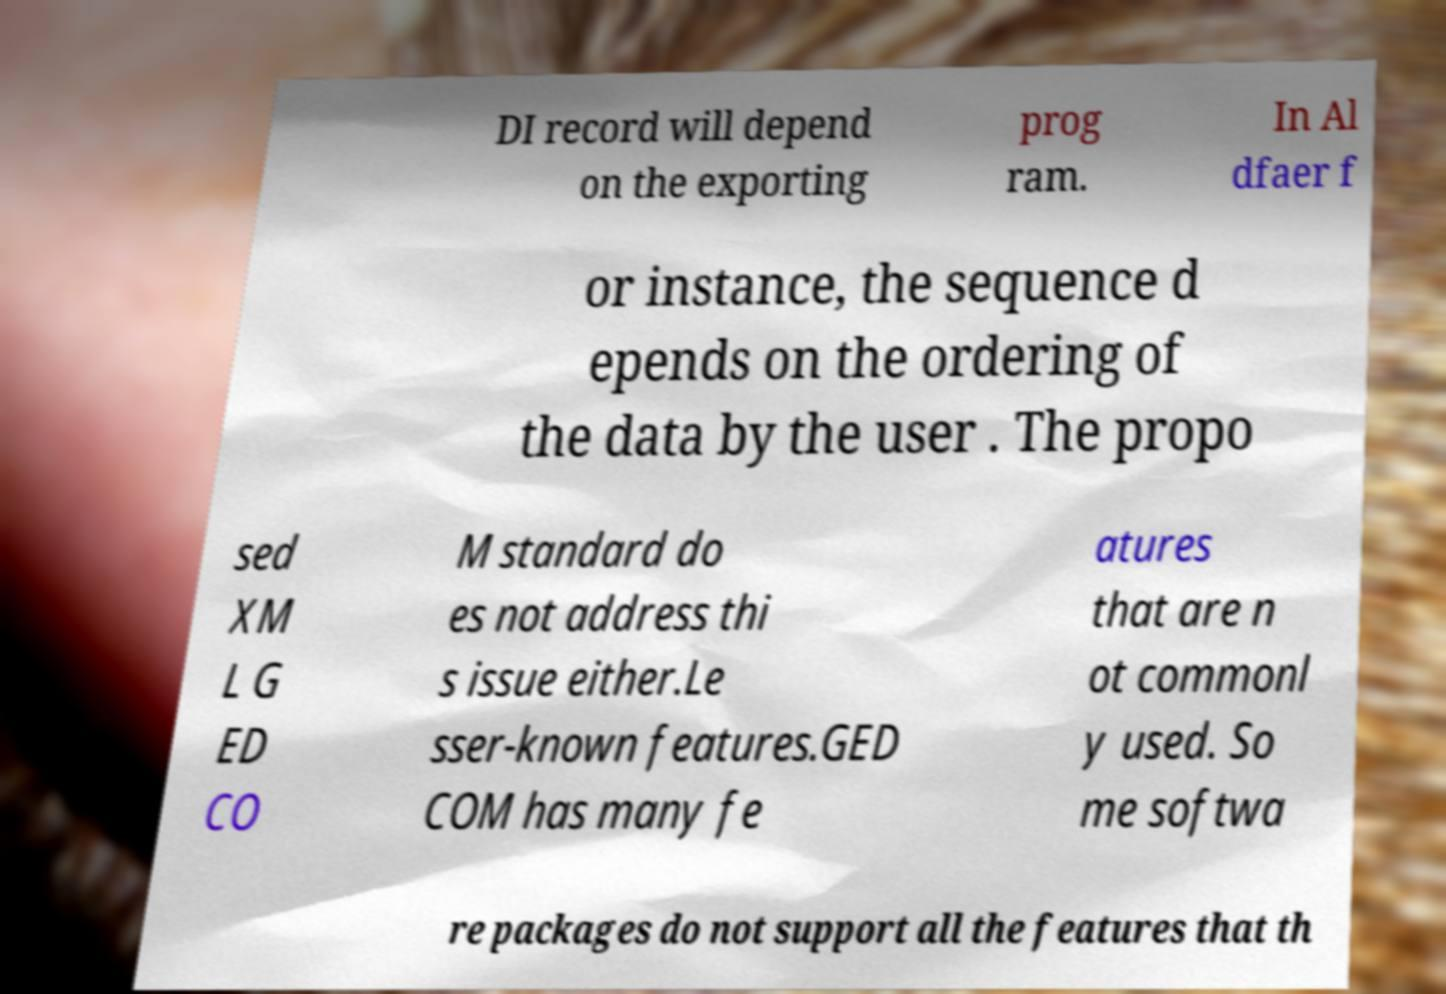Can you accurately transcribe the text from the provided image for me? DI record will depend on the exporting prog ram. In Al dfaer f or instance, the sequence d epends on the ordering of the data by the user . The propo sed XM L G ED CO M standard do es not address thi s issue either.Le sser-known features.GED COM has many fe atures that are n ot commonl y used. So me softwa re packages do not support all the features that th 